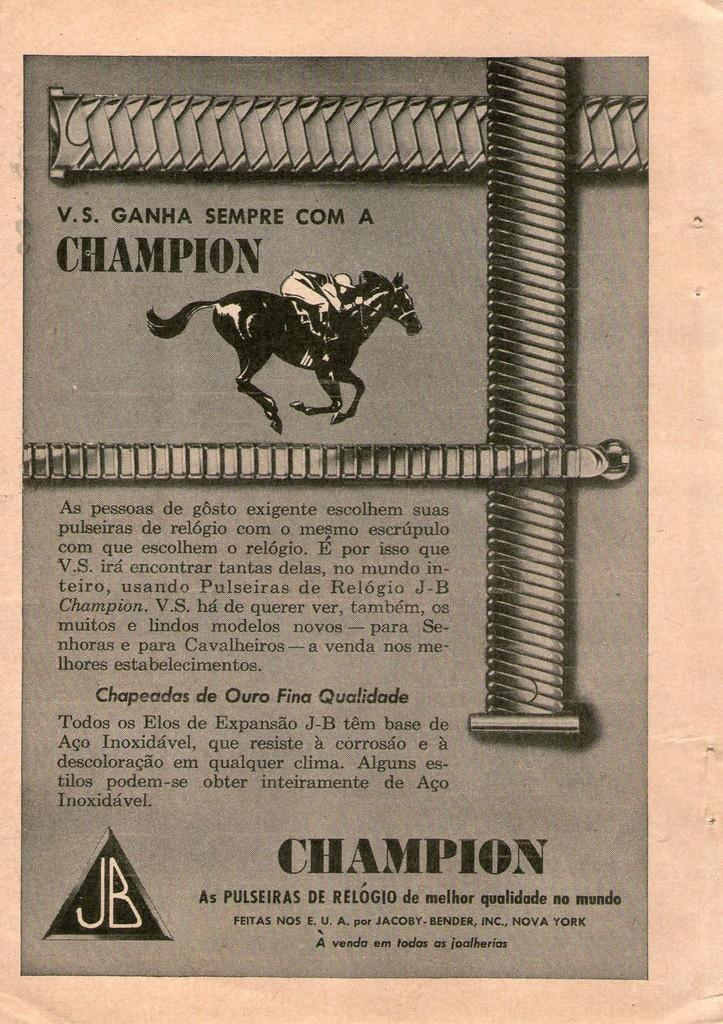What is the main subject of the image? The main subject of the image is a page. What is depicted on the page? There is a person sitting on a horse on the page. Are there any words or letters on the page? Yes, there is some text on the page. What type of key is being used to unlock the minute on the horse's back? There is no key or lock present in the image; it features a person sitting on a horse on a page with some text. What cable is connected to the horse's saddle in the image? There is no cable present in the image; it features a person sitting on a horse on a page with some text. 